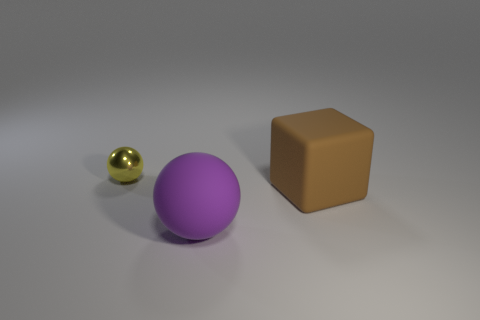Add 2 small rubber things. How many objects exist? 5 Subtract all spheres. How many objects are left? 1 Add 2 purple rubber things. How many purple rubber things exist? 3 Subtract 0 blue cylinders. How many objects are left? 3 Subtract all cylinders. Subtract all small things. How many objects are left? 2 Add 1 brown matte things. How many brown matte things are left? 2 